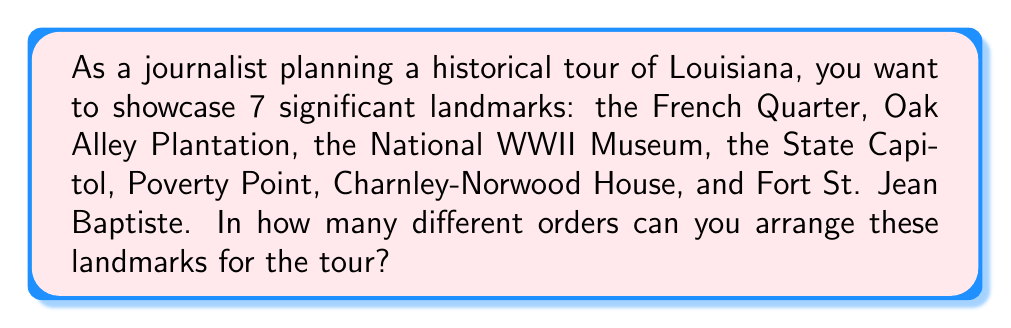Can you answer this question? To solve this problem, we need to use the concept of permutations. Since we are arranging all 7 landmarks without repeating any, this is a straightforward permutation problem.

The number of permutations of n distinct objects is given by:

$$P(n) = n!$$

Where $n!$ represents the factorial of n.

In this case, we have 7 landmarks, so:

$$P(7) = 7!$$

Let's calculate this step-by-step:

$$\begin{align}
7! &= 7 \times 6 \times 5 \times 4 \times 3 \times 2 \times 1 \\
&= 42 \times 5 \times 4 \times 3 \times 2 \times 1 \\
&= 210 \times 4 \times 3 \times 2 \times 1 \\
&= 840 \times 3 \times 2 \times 1 \\
&= 2,520 \times 2 \times 1 \\
&= 5,040
\end{align}$$

Therefore, there are 5,040 different ways to arrange these 7 historical landmarks for the tour.
Answer: $5,040$ 